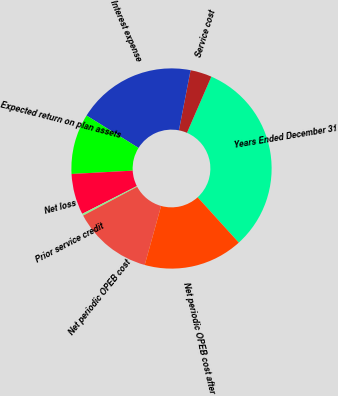Convert chart to OTSL. <chart><loc_0><loc_0><loc_500><loc_500><pie_chart><fcel>Years Ended December 31<fcel>Service cost<fcel>Interest expense<fcel>Expected return on plan assets<fcel>Net loss<fcel>Prior service credit<fcel>Net periodic OPEB cost<fcel>Net periodic OPEB cost after<nl><fcel>31.76%<fcel>3.46%<fcel>19.18%<fcel>9.75%<fcel>6.6%<fcel>0.32%<fcel>12.89%<fcel>16.04%<nl></chart> 